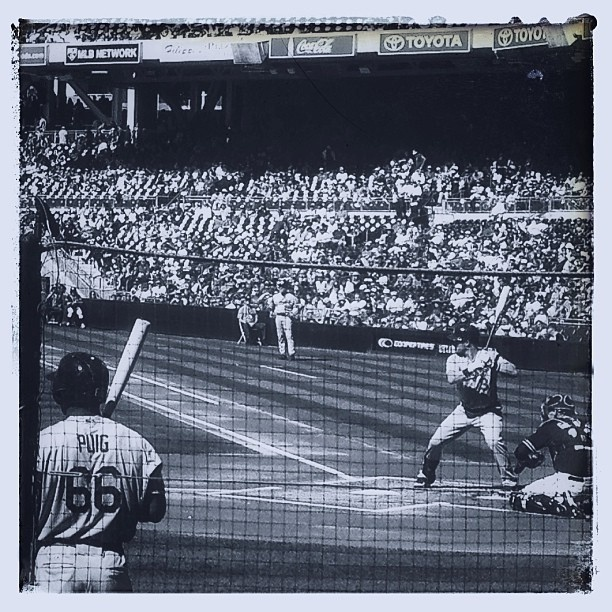Describe the objects in this image and their specific colors. I can see people in lavender, black, gray, and darkgray tones, people in lavender, black, and darkgray tones, people in lavender, black, and gray tones, people in lavender, black, and gray tones, and people in lavender, gray, darkgray, and black tones in this image. 